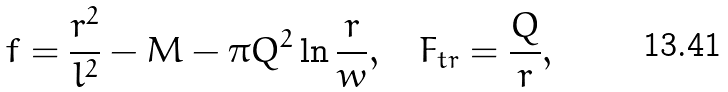<formula> <loc_0><loc_0><loc_500><loc_500>f = \frac { r ^ { 2 } } { l ^ { 2 } } - M - \pi Q ^ { 2 } \ln \frac { r } { w } , \quad F _ { t r } = \frac { Q } { r } ,</formula> 